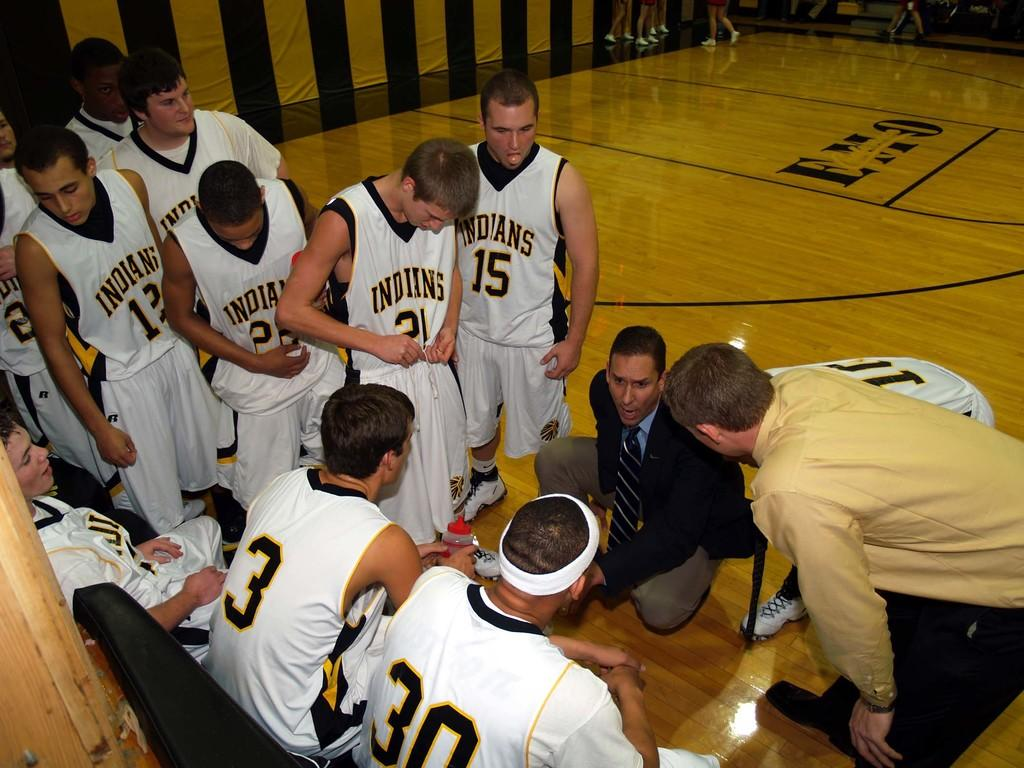Provide a one-sentence caption for the provided image. Several basketball players with the team name Indians written on their shirts. 